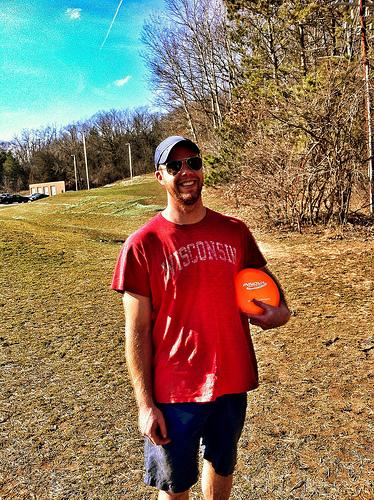Identify any text visible on the man's clothing or the frisbee. White words are on the orange frisbee, and faded words can be seen on the red t-shirt. What is the color of the frisbee and who is holding it? The frisbee is orange and held by a man in a red shirt. What kind of trees can be seen in the image and where are they located? A group of trees, with and without leaves, is growing behind the brown building, forming the edge of the woods. Describe the condition of the ground near the man with the frisbee. The ground near the man has sticks and dirt, and there is a small piece of branch on the ground. Describe the environment where the man with the frisbee is standing. The man is standing in a field, with woods in the background, a blue sky above, and a brown building nearby. What are some noticeable features on the man's face and hand? The man has a beard on his face, veins in his hand, and he's wearing sunglasses over his eyes. Choose an object in the image and describe its position relative to the man with the frisbee. A brown building with four white doors is located behind and to the left of the man with the frisbee. Pick any item in the image and provide a short description of it. The man with the frisbee is wearing a pair of dark blue shorts that reach down to his knees. Provide a brief description of the attire worn by the person holding the frisbee. The man is wearing a red t-shirt, navy blue shorts, a blue cap, and black sunglasses. Point out some items in the background behind the man with the frisbee. There are several dark cars parked in a parking lot, light poles mounted behind the brown building, and tall scrub bushes growing in the field. Look at the man wearing a striped green shirt. The man in the image is wearing a red tshirt that says Wisconsin, not a green striped shirt. Observe the huge red flowers blooming in the woods behind the man. There are no red flowers in the image, just woods and trees growing behind the brown building. The sunglasses on the man's face are blue and round. The man is wearing black sunglasses, not blue and round ones. Find the smiley face on the orange frisbee. The frisbee has white words on it, not a smiley face. Check if there are two small kittens playing beside the man. There are no kittens in the image, just the man with frisbee and other objects. Is there a woman with a purple dress in the picture? There is no woman in the image, only a man wearing a red shirt and blue shorts. Find the yellow and black frisbee in man's hand. The frisbee in the man's hand is orange and white, not yellow and black. Does the man have a red hat on his head? The man is wearing a blue cap on his head, not a red hat. Is there a helicopter hovering over the trees? There is no helicopter in the image, only a blue sky with an airplane exhaust and a white cloud. There is a huge gray building with six doors in the background. The building in the image is a large brown building with four white doors, not a gray building with six doors. 